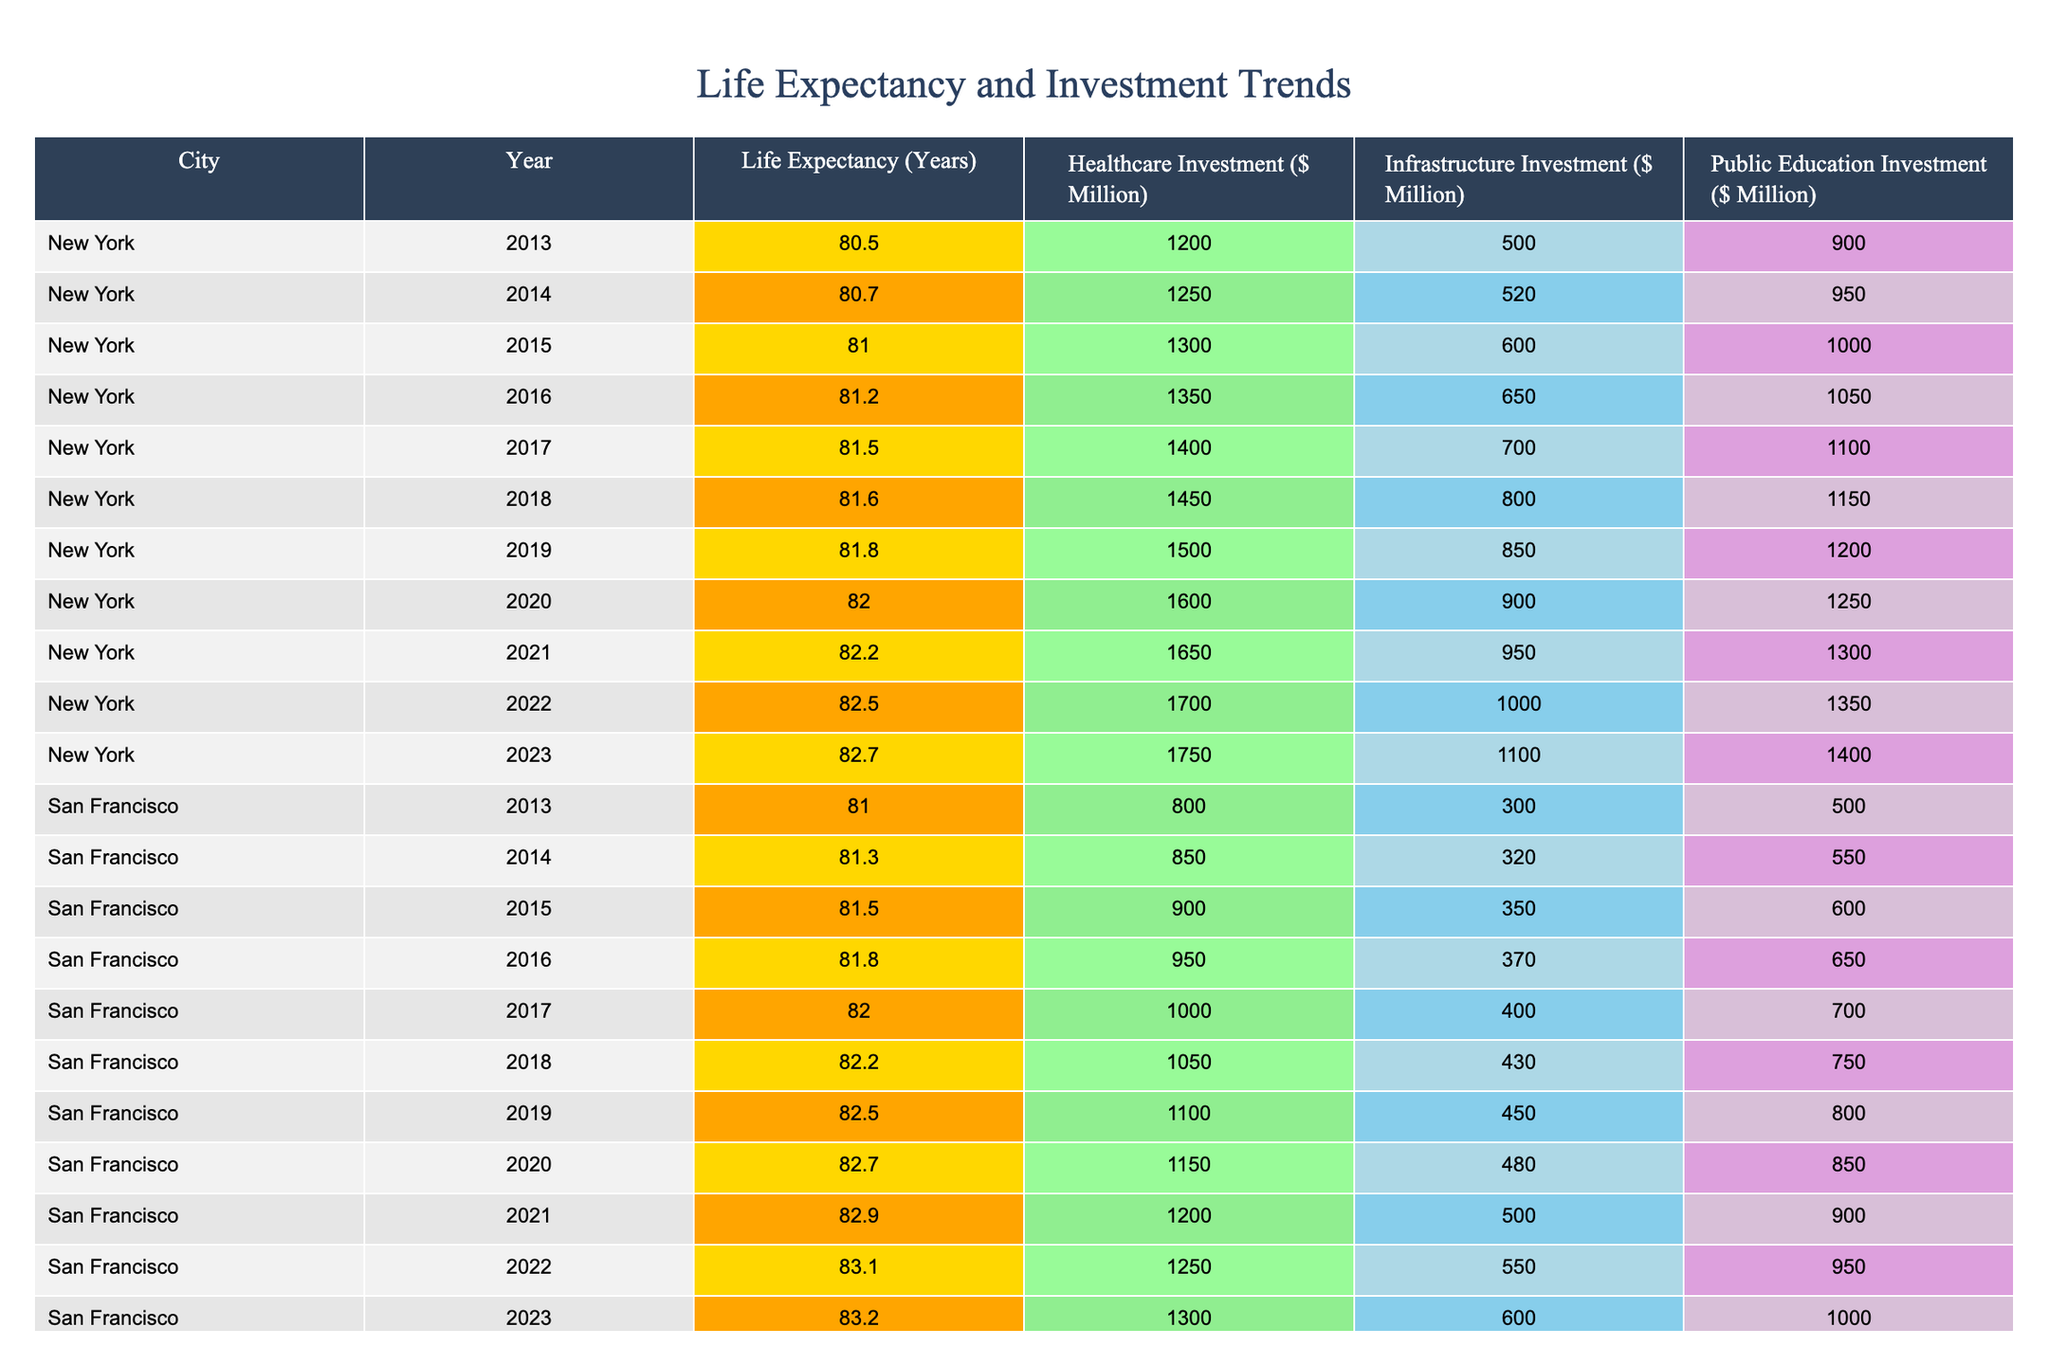What was the life expectancy in New York in 2016? The table indicates that the life expectancy in New York for the year 2016 was recorded as 81.2 years.
Answer: 81.2 years What was the total infrastructure investment in San Francisco over the last decade (2013-2023)? To compute the total infrastructure investment for San Francisco, we sum the investments for each year: 300 + 320 + 350 + 370 + 400 + 430 + 450 + 480 + 500 + 550 + 600 = 4350 million dollars.
Answer: 4350 million dollars Did life expectancy in Los Angeles increase in 2021 compared to 2020? By comparing the values in 2020 (80.2 years) and 2021 (80.4 years) for Los Angeles, we find an increase of 0.2 years from 2020 to 2021.
Answer: Yes Which city had the highest healthcare investment in 2022? In 2022, New York had the highest healthcare investment at 1700 million dollars compared to San Francisco's 1250 million dollars and Los Angeles' 1050 million dollars.
Answer: New York What is the average life expectancy across all three cities in 2023? First, we find the life expectancies for 2023: New York (82.7), San Francisco (83.2), and Los Angeles (80.8). The average is calculated as (82.7 + 83.2 + 80.8) / 3 = 82.23 years.
Answer: 82.23 years Was there a year when infrastructure investment in New York decreased compared to the previous year? Checking the values for infrastructure investment in New York from 2014 to 2023, we see an increase each year, indicating there were no decreases during this period.
Answer: No What was the increase in public education investment from 2013 to 2023 in Los Angeles? The public education investment in Los Angeles was 700 million dollars in 2013 and 810 million dollars in 2023. The increase is calculated as 810 - 700 = 110 million dollars.
Answer: 110 million dollars In which year did San Francisco have the lowest life expectancy, and what was that value? By reviewing the life expectancy across the years, we find that San Francisco's lowest life expectancy was 81.0 years in 2013.
Answer: 81.0 years How much more was spent on healthcare in New York in 2023 compared to Los Angeles in the same year? In 2023, healthcare investment in New York was 1750 million dollars, while in Los Angeles, it was 1100 million dollars. The difference is 1750 - 1100 = 650 million dollars.
Answer: 650 million dollars 